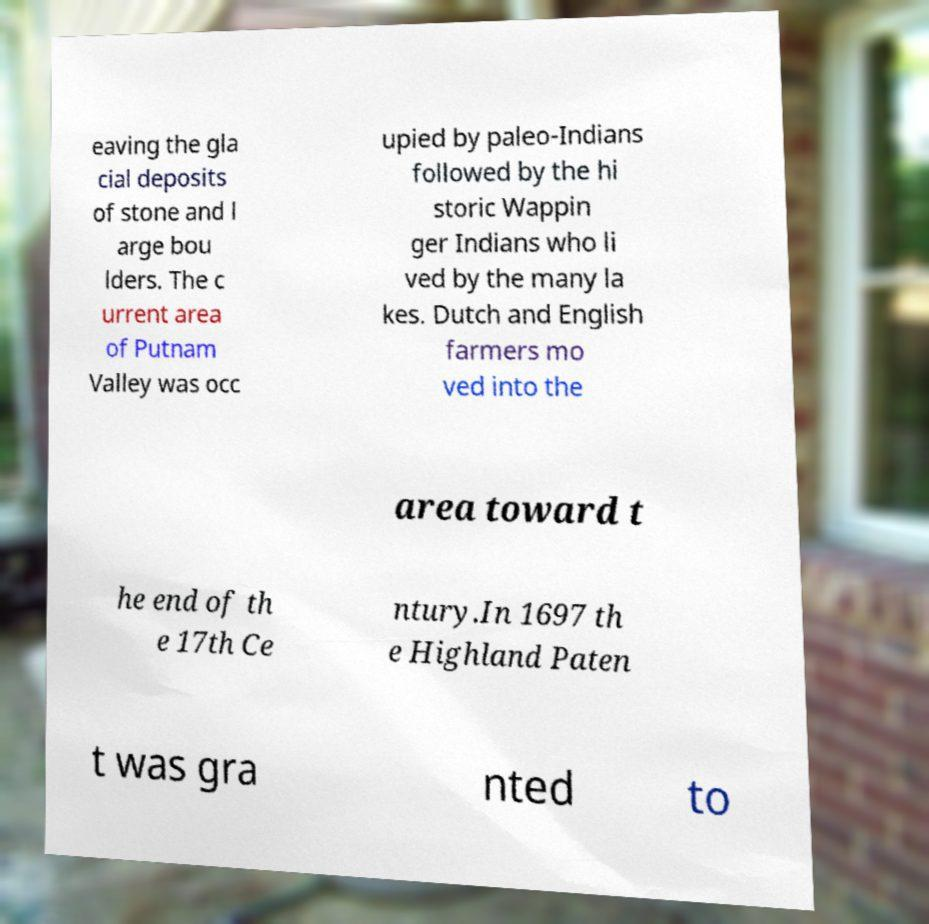Please identify and transcribe the text found in this image. eaving the gla cial deposits of stone and l arge bou lders. The c urrent area of Putnam Valley was occ upied by paleo-Indians followed by the hi storic Wappin ger Indians who li ved by the many la kes. Dutch and English farmers mo ved into the area toward t he end of th e 17th Ce ntury.In 1697 th e Highland Paten t was gra nted to 